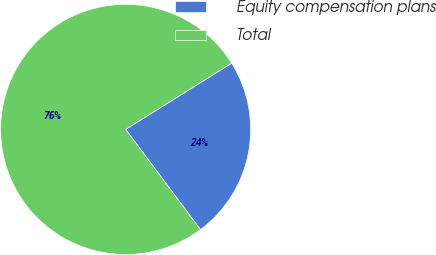<chart> <loc_0><loc_0><loc_500><loc_500><pie_chart><fcel>Equity compensation plans<fcel>Total<nl><fcel>23.68%<fcel>76.32%<nl></chart> 